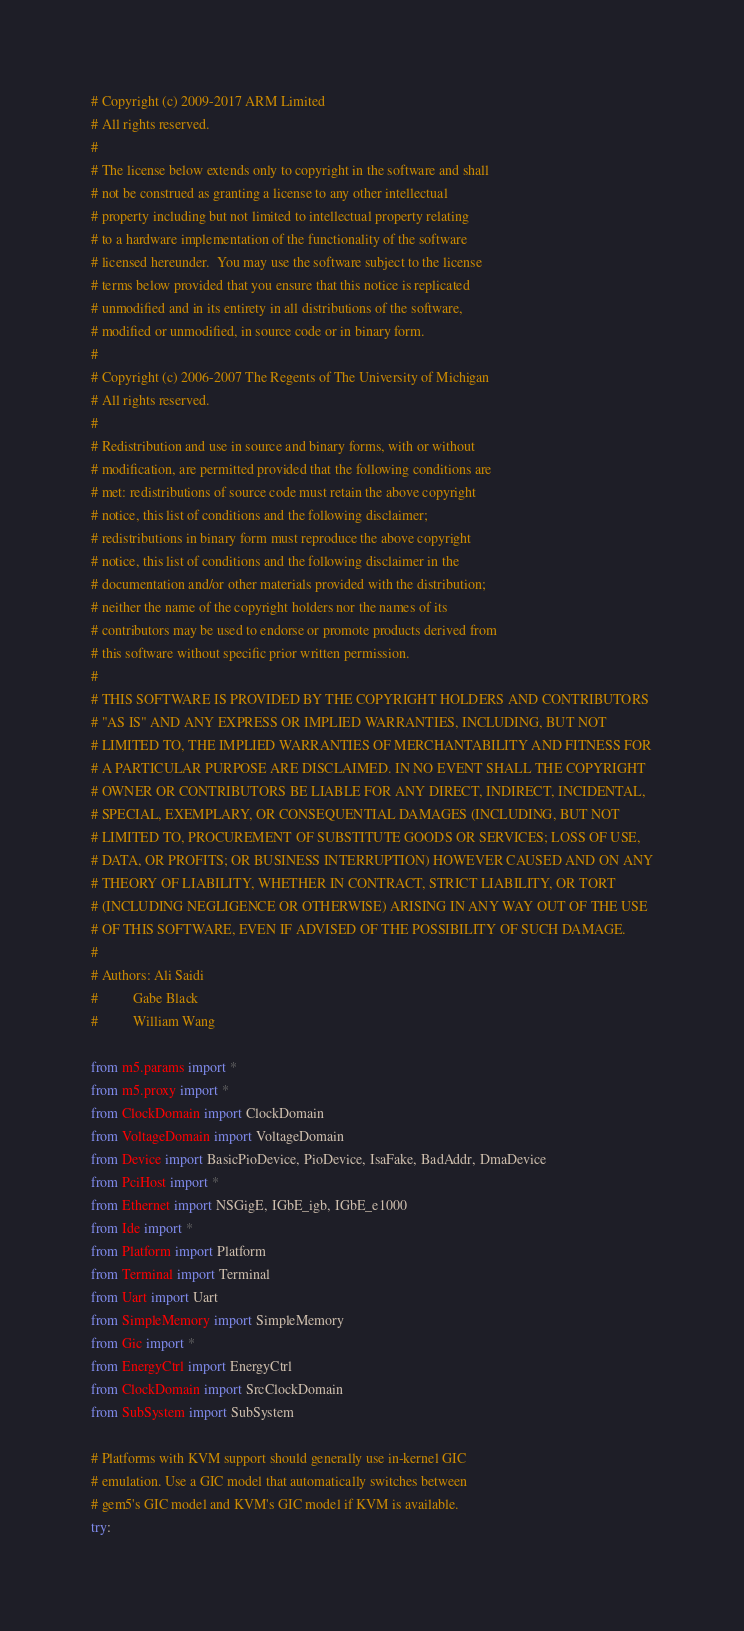<code> <loc_0><loc_0><loc_500><loc_500><_Python_># Copyright (c) 2009-2017 ARM Limited
# All rights reserved.
#
# The license below extends only to copyright in the software and shall
# not be construed as granting a license to any other intellectual
# property including but not limited to intellectual property relating
# to a hardware implementation of the functionality of the software
# licensed hereunder.  You may use the software subject to the license
# terms below provided that you ensure that this notice is replicated
# unmodified and in its entirety in all distributions of the software,
# modified or unmodified, in source code or in binary form.
#
# Copyright (c) 2006-2007 The Regents of The University of Michigan
# All rights reserved.
#
# Redistribution and use in source and binary forms, with or without
# modification, are permitted provided that the following conditions are
# met: redistributions of source code must retain the above copyright
# notice, this list of conditions and the following disclaimer;
# redistributions in binary form must reproduce the above copyright
# notice, this list of conditions and the following disclaimer in the
# documentation and/or other materials provided with the distribution;
# neither the name of the copyright holders nor the names of its
# contributors may be used to endorse or promote products derived from
# this software without specific prior written permission.
#
# THIS SOFTWARE IS PROVIDED BY THE COPYRIGHT HOLDERS AND CONTRIBUTORS
# "AS IS" AND ANY EXPRESS OR IMPLIED WARRANTIES, INCLUDING, BUT NOT
# LIMITED TO, THE IMPLIED WARRANTIES OF MERCHANTABILITY AND FITNESS FOR
# A PARTICULAR PURPOSE ARE DISCLAIMED. IN NO EVENT SHALL THE COPYRIGHT
# OWNER OR CONTRIBUTORS BE LIABLE FOR ANY DIRECT, INDIRECT, INCIDENTAL,
# SPECIAL, EXEMPLARY, OR CONSEQUENTIAL DAMAGES (INCLUDING, BUT NOT
# LIMITED TO, PROCUREMENT OF SUBSTITUTE GOODS OR SERVICES; LOSS OF USE,
# DATA, OR PROFITS; OR BUSINESS INTERRUPTION) HOWEVER CAUSED AND ON ANY
# THEORY OF LIABILITY, WHETHER IN CONTRACT, STRICT LIABILITY, OR TORT
# (INCLUDING NEGLIGENCE OR OTHERWISE) ARISING IN ANY WAY OUT OF THE USE
# OF THIS SOFTWARE, EVEN IF ADVISED OF THE POSSIBILITY OF SUCH DAMAGE.
#
# Authors: Ali Saidi
#          Gabe Black
#          William Wang

from m5.params import *
from m5.proxy import *
from ClockDomain import ClockDomain
from VoltageDomain import VoltageDomain
from Device import BasicPioDevice, PioDevice, IsaFake, BadAddr, DmaDevice
from PciHost import *
from Ethernet import NSGigE, IGbE_igb, IGbE_e1000
from Ide import *
from Platform import Platform
from Terminal import Terminal
from Uart import Uart
from SimpleMemory import SimpleMemory
from Gic import *
from EnergyCtrl import EnergyCtrl
from ClockDomain import SrcClockDomain
from SubSystem import SubSystem

# Platforms with KVM support should generally use in-kernel GIC
# emulation. Use a GIC model that automatically switches between
# gem5's GIC model and KVM's GIC model if KVM is available.
try:</code> 